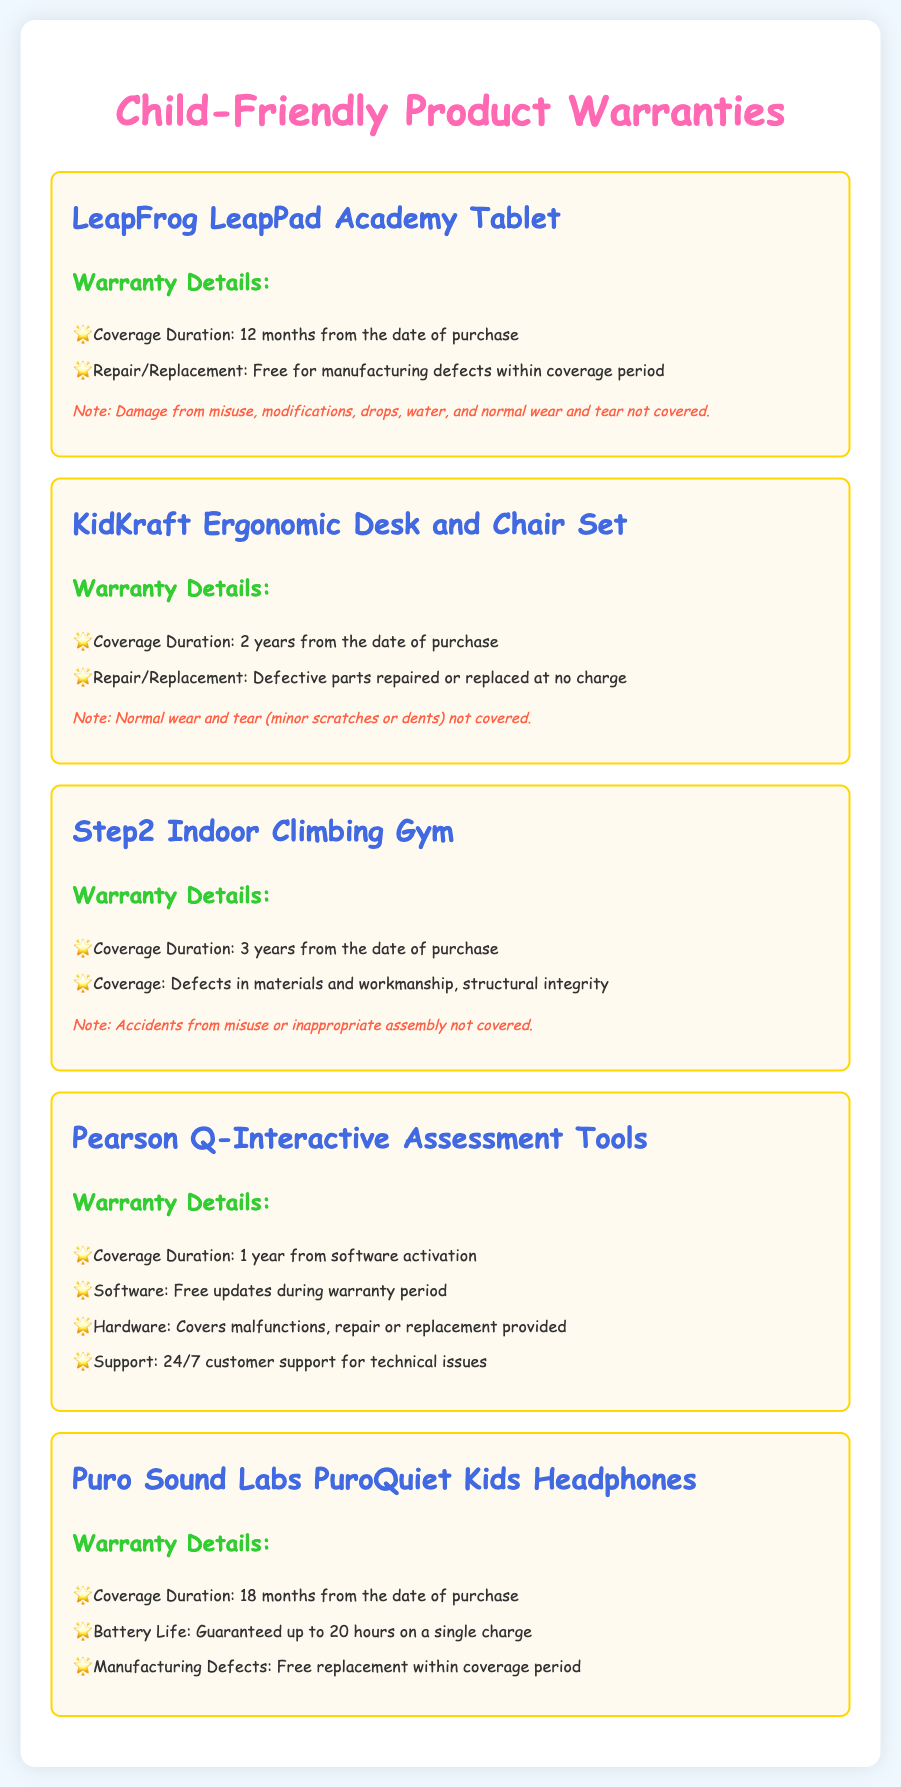What is the warranty duration for the LeapFrog LeapPad Academy Tablet? The warranty duration is stated in the document as 12 months from the date of purchase.
Answer: 12 months What kind of damage is not covered under the LeapFrog warranty? The document lists damage from misuse, modifications, drops, water, and normal wear and tear as exclusions.
Answer: Misuse, modifications, drops, water, normal wear and tear How long is the warranty coverage for the KidKraft Ergonomic Desk and Chair Set? The document specifies a warranty duration of 2 years from the date of purchase.
Answer: 2 years What support is included with the Pearson Q-Interactive Assessment Tools? The document states that 24/7 customer support is provided for technical issues during the warranty period.
Answer: 24/7 customer support Is battery life guaranteed for the Puro Sound Labs PuroQuiet Kids Headphones? The document confirms that battery life is guaranteed up to 20 hours on a single charge.
Answer: Yes, 20 hours What is the maximum coverage duration for the Step2 Indoor Climbing Gym? The document notes that the coverage duration is 3 years from the date of purchase.
Answer: 3 years Which furniture item has a repair or replacement policy for defective parts? The document indicates that the KidKraft Ergonomic Desk and Chair Set has a repair or replacement policy for defective parts.
Answer: KidKraft Ergonomic Desk and Chair Set What is specifically excluded from the Step2 Indoor Climbing Gym warranty? The document mentions that accidents from misuse or inappropriate assembly are not covered.
Answer: Misuse or inappropriate assembly Are hardware repairs covered under the Pearson Q-Interactive Assessment Tools warranty? The document states that malfunctions in hardware are covered by repair or replacement.
Answer: Yes, hardware repairs are covered 